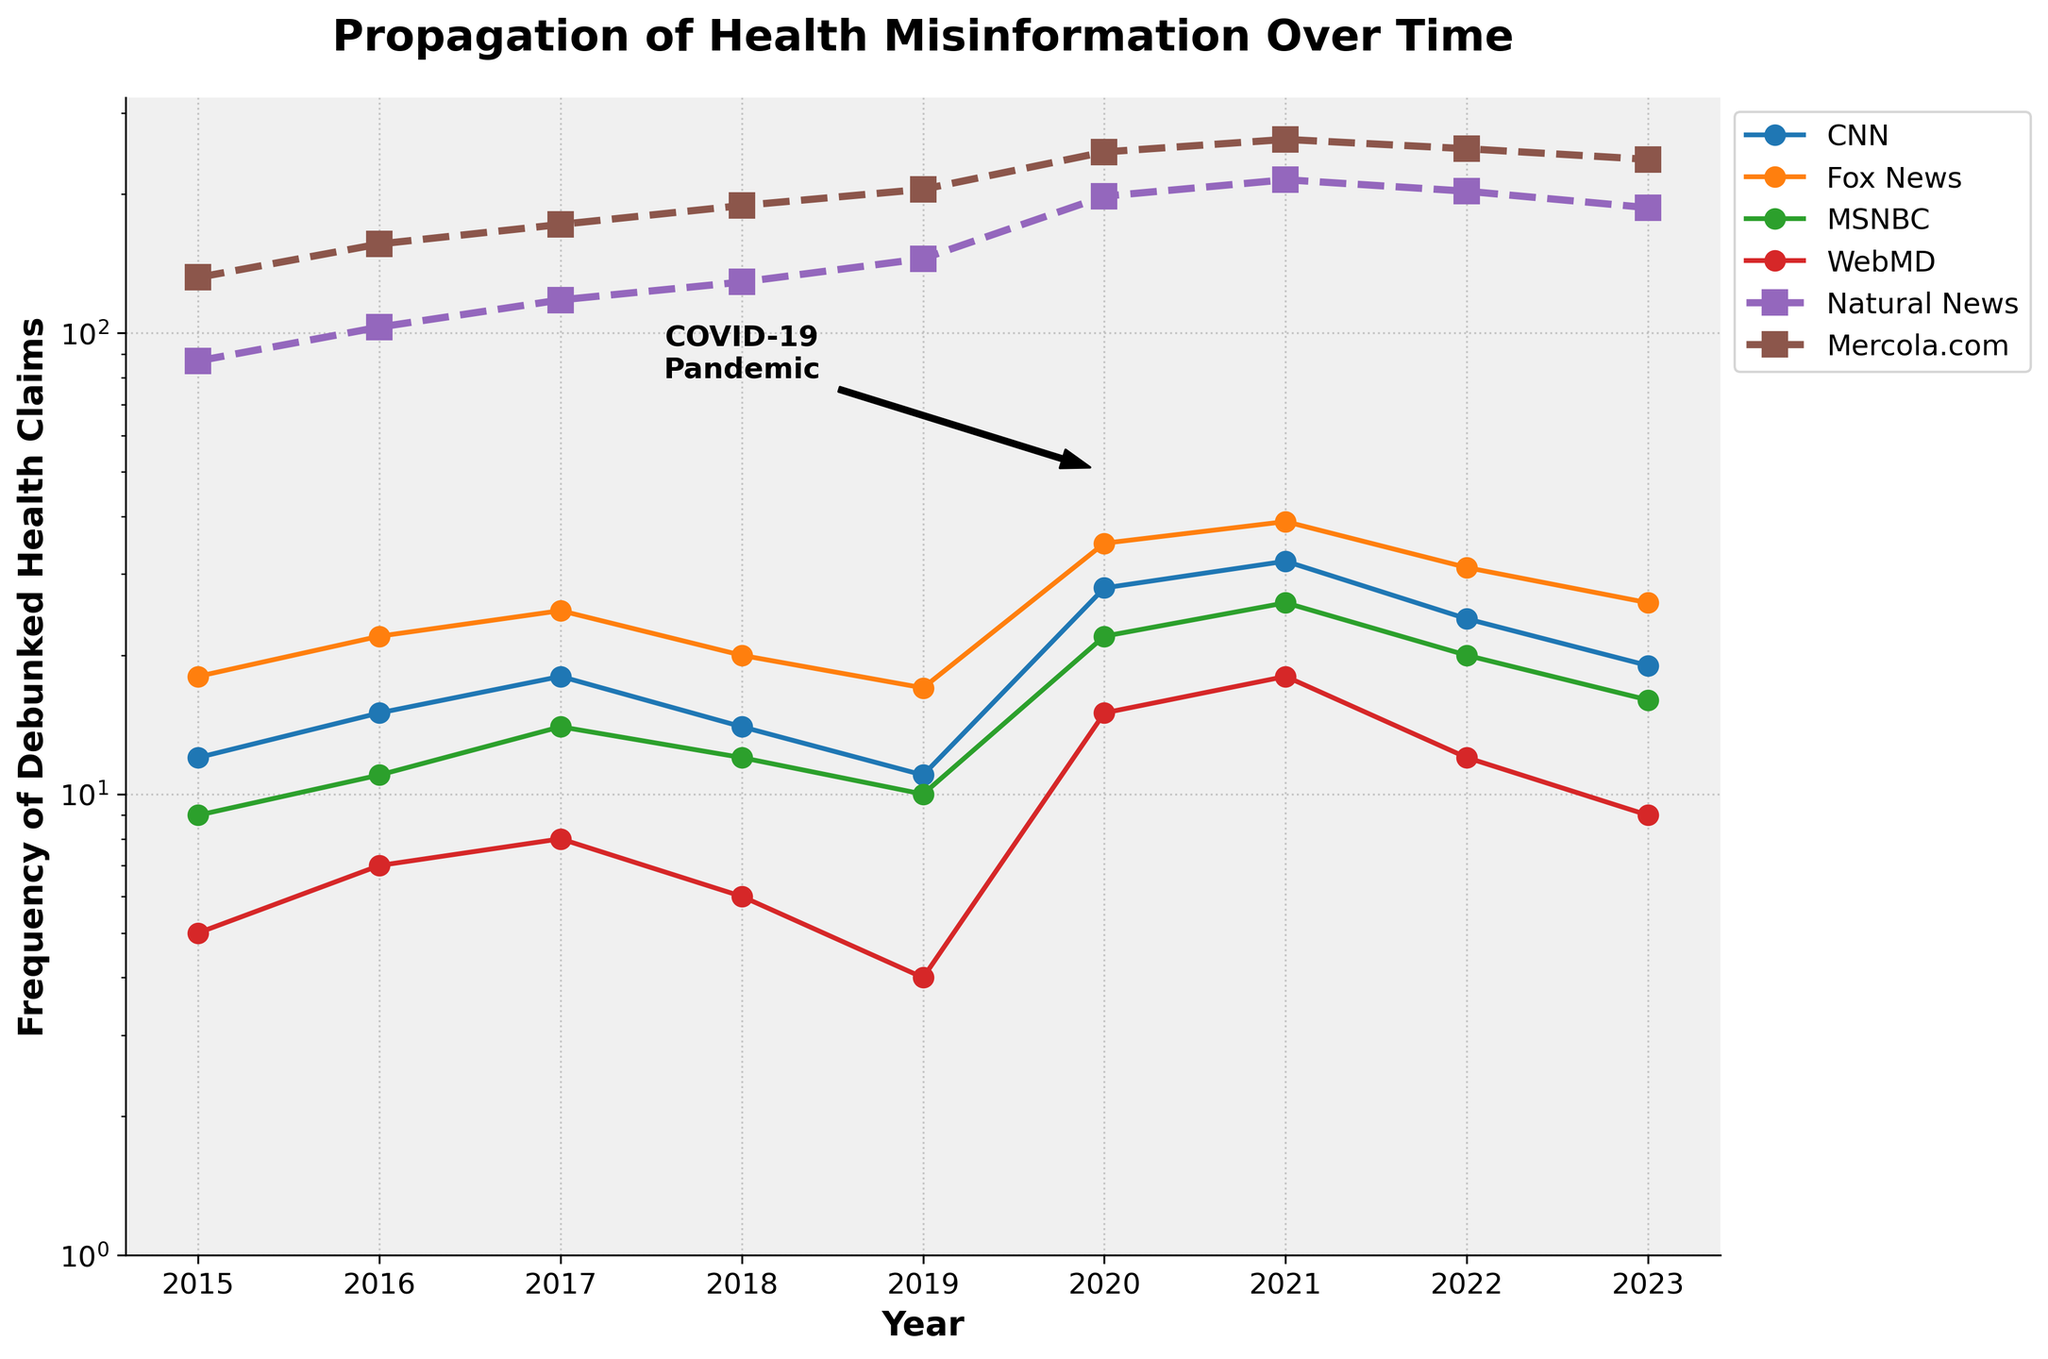What's the overall trend in debunked health claims for Fox News from 2015 to 2023? The frequency shows an overall upward trend, increasing from 18 in 2015 to a peak of 39 in 2021 before declining to 26 in 2023.
Answer: Upward trend Compare the frequency of debunked health claims on WebMD in 2020 with CNN in the same year. Which one is higher? In 2020, WebMD has a frequency of 15, whereas CNN has a frequency of 28.
Answer: CNN What years have the highest frequency of debunked health claims for both Natural News and Mercola.com? Natural News peaks in 2021 with 215, while Mercola.com peaks in 2021 with 263.
Answer: 2021 What is the difference in the frequency of debunked health claims for MSNBC between 2021 and 2022? MSNBC has a frequency of 26 in 2021 and 20 in 2022. The difference is 26 - 20 = 6.
Answer: 6 How does the frequency of debunked health claims on alternative media outlets in 2020 compare to those on mainstream media outlets in the same year? The sum for mainstream outlets (CNN, Fox News, MSNBC, WebMD) for 2020 is 28 + 35 + 22 + 15 = 100. For alternative outlets (Natural News, Mercola.com) it’s 198 + 247 = 445. 445 is significantly higher than 100.
Answer: Alternative outlets higher What is the average frequency of debunked health claims on CNN from 2015 to 2023? The frequencies for CNN from 2015 to 2023 are 12, 15, 18, 14, 11, 28, 32, 24, and 19. The sum is 173 and there are 9 years. The average is 173/9 ≈ 19.22.
Answer: 19.22 Which year shows the largest increase in debunked health claims for CNN compared to the previous year? The largest increase for CNN occurs between 2019 (11) and 2020 (28), a difference of 17.
Answer: 2020 What’s the trend in the total frequency of debunked health claims for mainstream media outlets (sum of CNN, Fox News, MSNBC, WebMD) from 2015 to 2023? Summing the frequencies for each year: 2015 (44); 2016 (55); 2017 (65); 2018 (52); 2019 (42); 2020 (100); 2021 (115); 2022 (87); 2023 (70). The trend is upward with peaks in the years around the COVID-19 pandemic (2020-2021).
Answer: Upward trend How does the visual representation indicate the impact of the COVID-19 pandemic on the spread of health misinformation? The plot includes an annotation for the COVID-19 pandemic in 2020, and there is a noticeable spike in the frequencies for all outlets in 2020.
Answer: Indicated by spike and annotation 